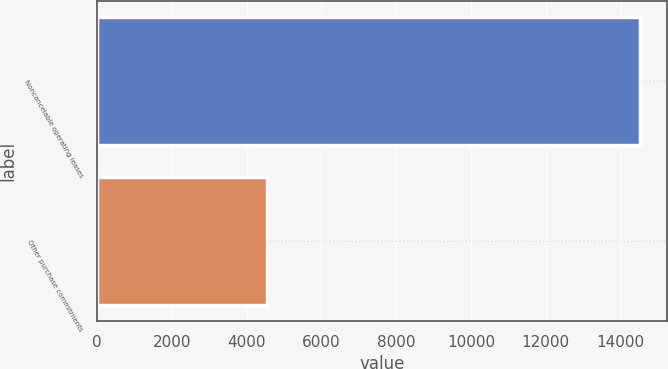<chart> <loc_0><loc_0><loc_500><loc_500><bar_chart><fcel>Noncancelable operating leases<fcel>Other purchase commitments<nl><fcel>14519<fcel>4538<nl></chart> 